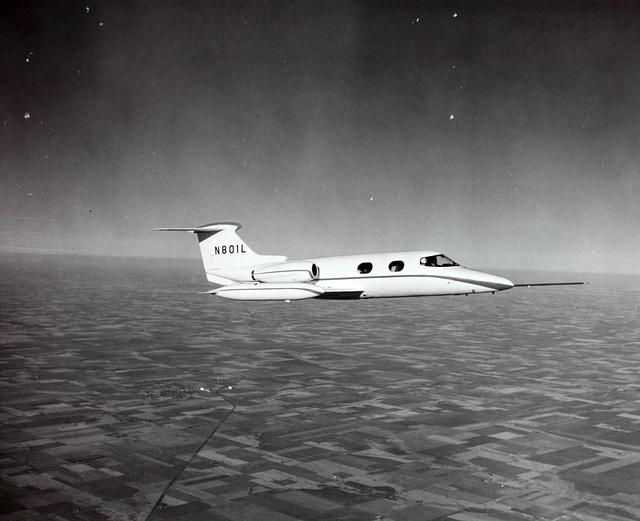What year was this taken?
Give a very brief answer. 1950. What color is the photo?
Answer briefly. Black and white. What type airplane is this?
Give a very brief answer. Jet. 